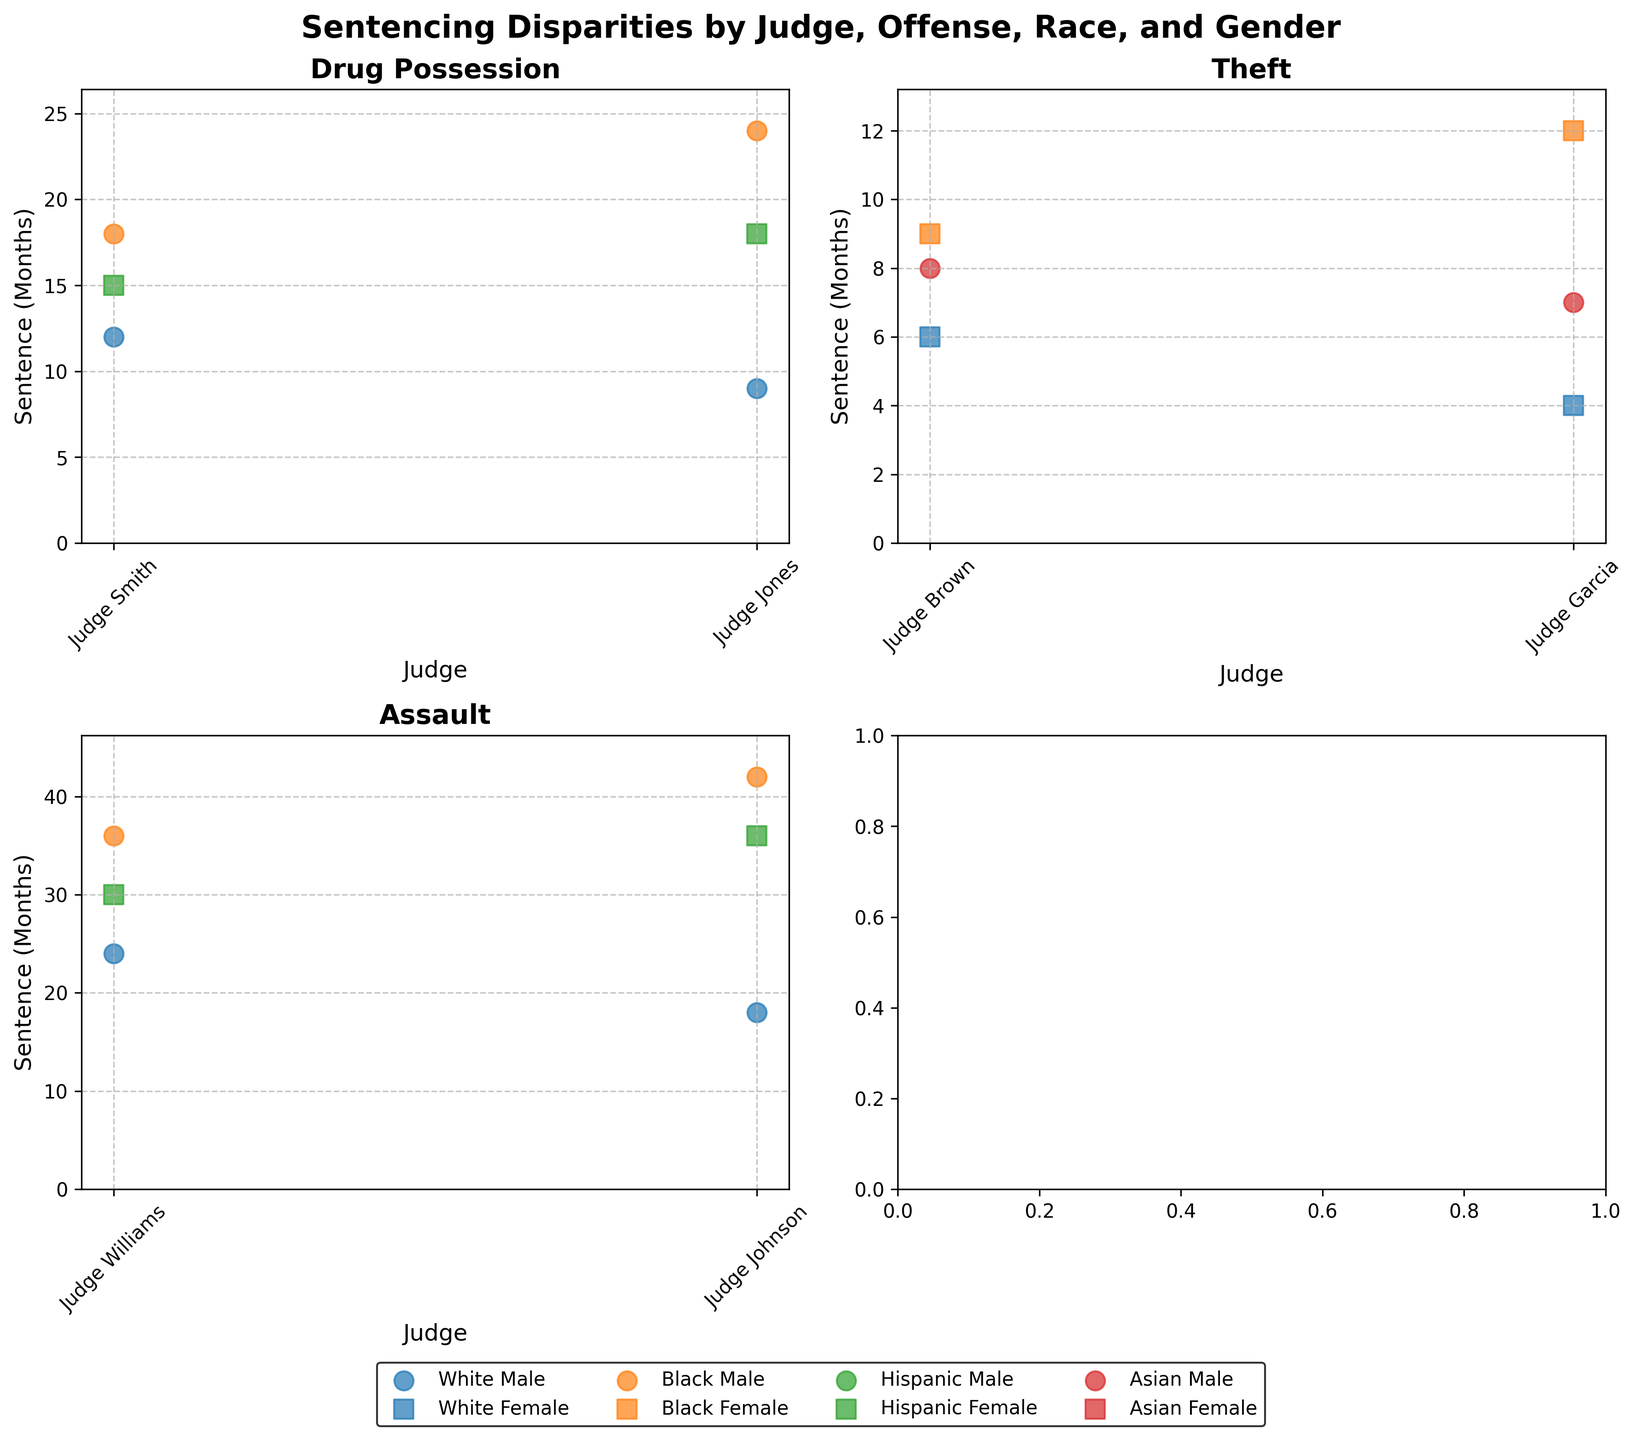How many judges are shown in the figure? The figure has multiple scatter plots, one for each offense. Each scatter plot shows points representing sentences by different judges. By counting unique judges in the figure, we find there are 6 judges.
Answer: 6 What is the title of the figure? The title is displayed at the top of the figure, summarizing the content focused on sentence disparities by various factors. The title reads "Sentencing Disparities by Judge, Offense, Race, and Gender."
Answer: Sentencing Disparities by Judge, Offense, Race, and Gender Which judge gave the highest sentence for assault to a Black male defendant? In the subplot for Assault, by comparing the Black male data points, Judge Johnson appears to have given the highest sentence at 42 months.
Answer: Judge Johnson Are there any offenses for which Hispanic female defendants received the highest sentence? By inspecting each subplot for sentences handed to Hispanic female defendants, they receive the highest sentence in the Assault offense, with Judge Johnson giving a 36-month sentence.
Answer: Assault Which offense generally has the least disparity in sentencing between different judges? Looking at the plots, the Drug Possession offense visually shows smaller variance in sentences across judges compared to the larger spread seen in Assault or Theft offenses.
Answer: Drug Possession What is the average sentence length for Drug Possession given by Judge Smith? Judge Smith has three data points for Drug Possession: 12 months (White Male), 18 months (Black Male), 15 months (Hispanic Female). The average is (12+18+15)/3 = 15 months.
Answer: 15 months For which offense does Judge Garcia appear more lenient compared to Judge Brown? By comparing the Theft sentences in the respective subplot, Judge Garcia's highest sentence is 12 months while Judge Brown’s is 9 months for the same offense.
Answer: Theft Which race and gender received the shortest sentence under Judge Williams for Assault? In the Assault plot, Judge Williams' shortest sentence is 24 months, given to a White male defendant.
Answer: White male Are there any visible patterns in sentencing disparities based on gender for the same race? Comparing data points of the same race across the scatter plots, males often receive slightly higher sentences than females for the same offenses and judges.
Answer: Males often receive higher sentences Do sentences for the same offense differ significantly from one judge to another for the White male defendants? By focusing on the subplots and comparing the sentences for White male defendants, significant differences are visible, especially in Drug Possession and Assault offenses.
Answer: Yes 